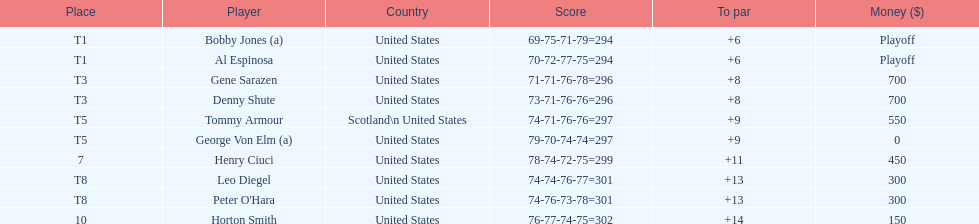Who was the last player in the top 10? Horton Smith. 